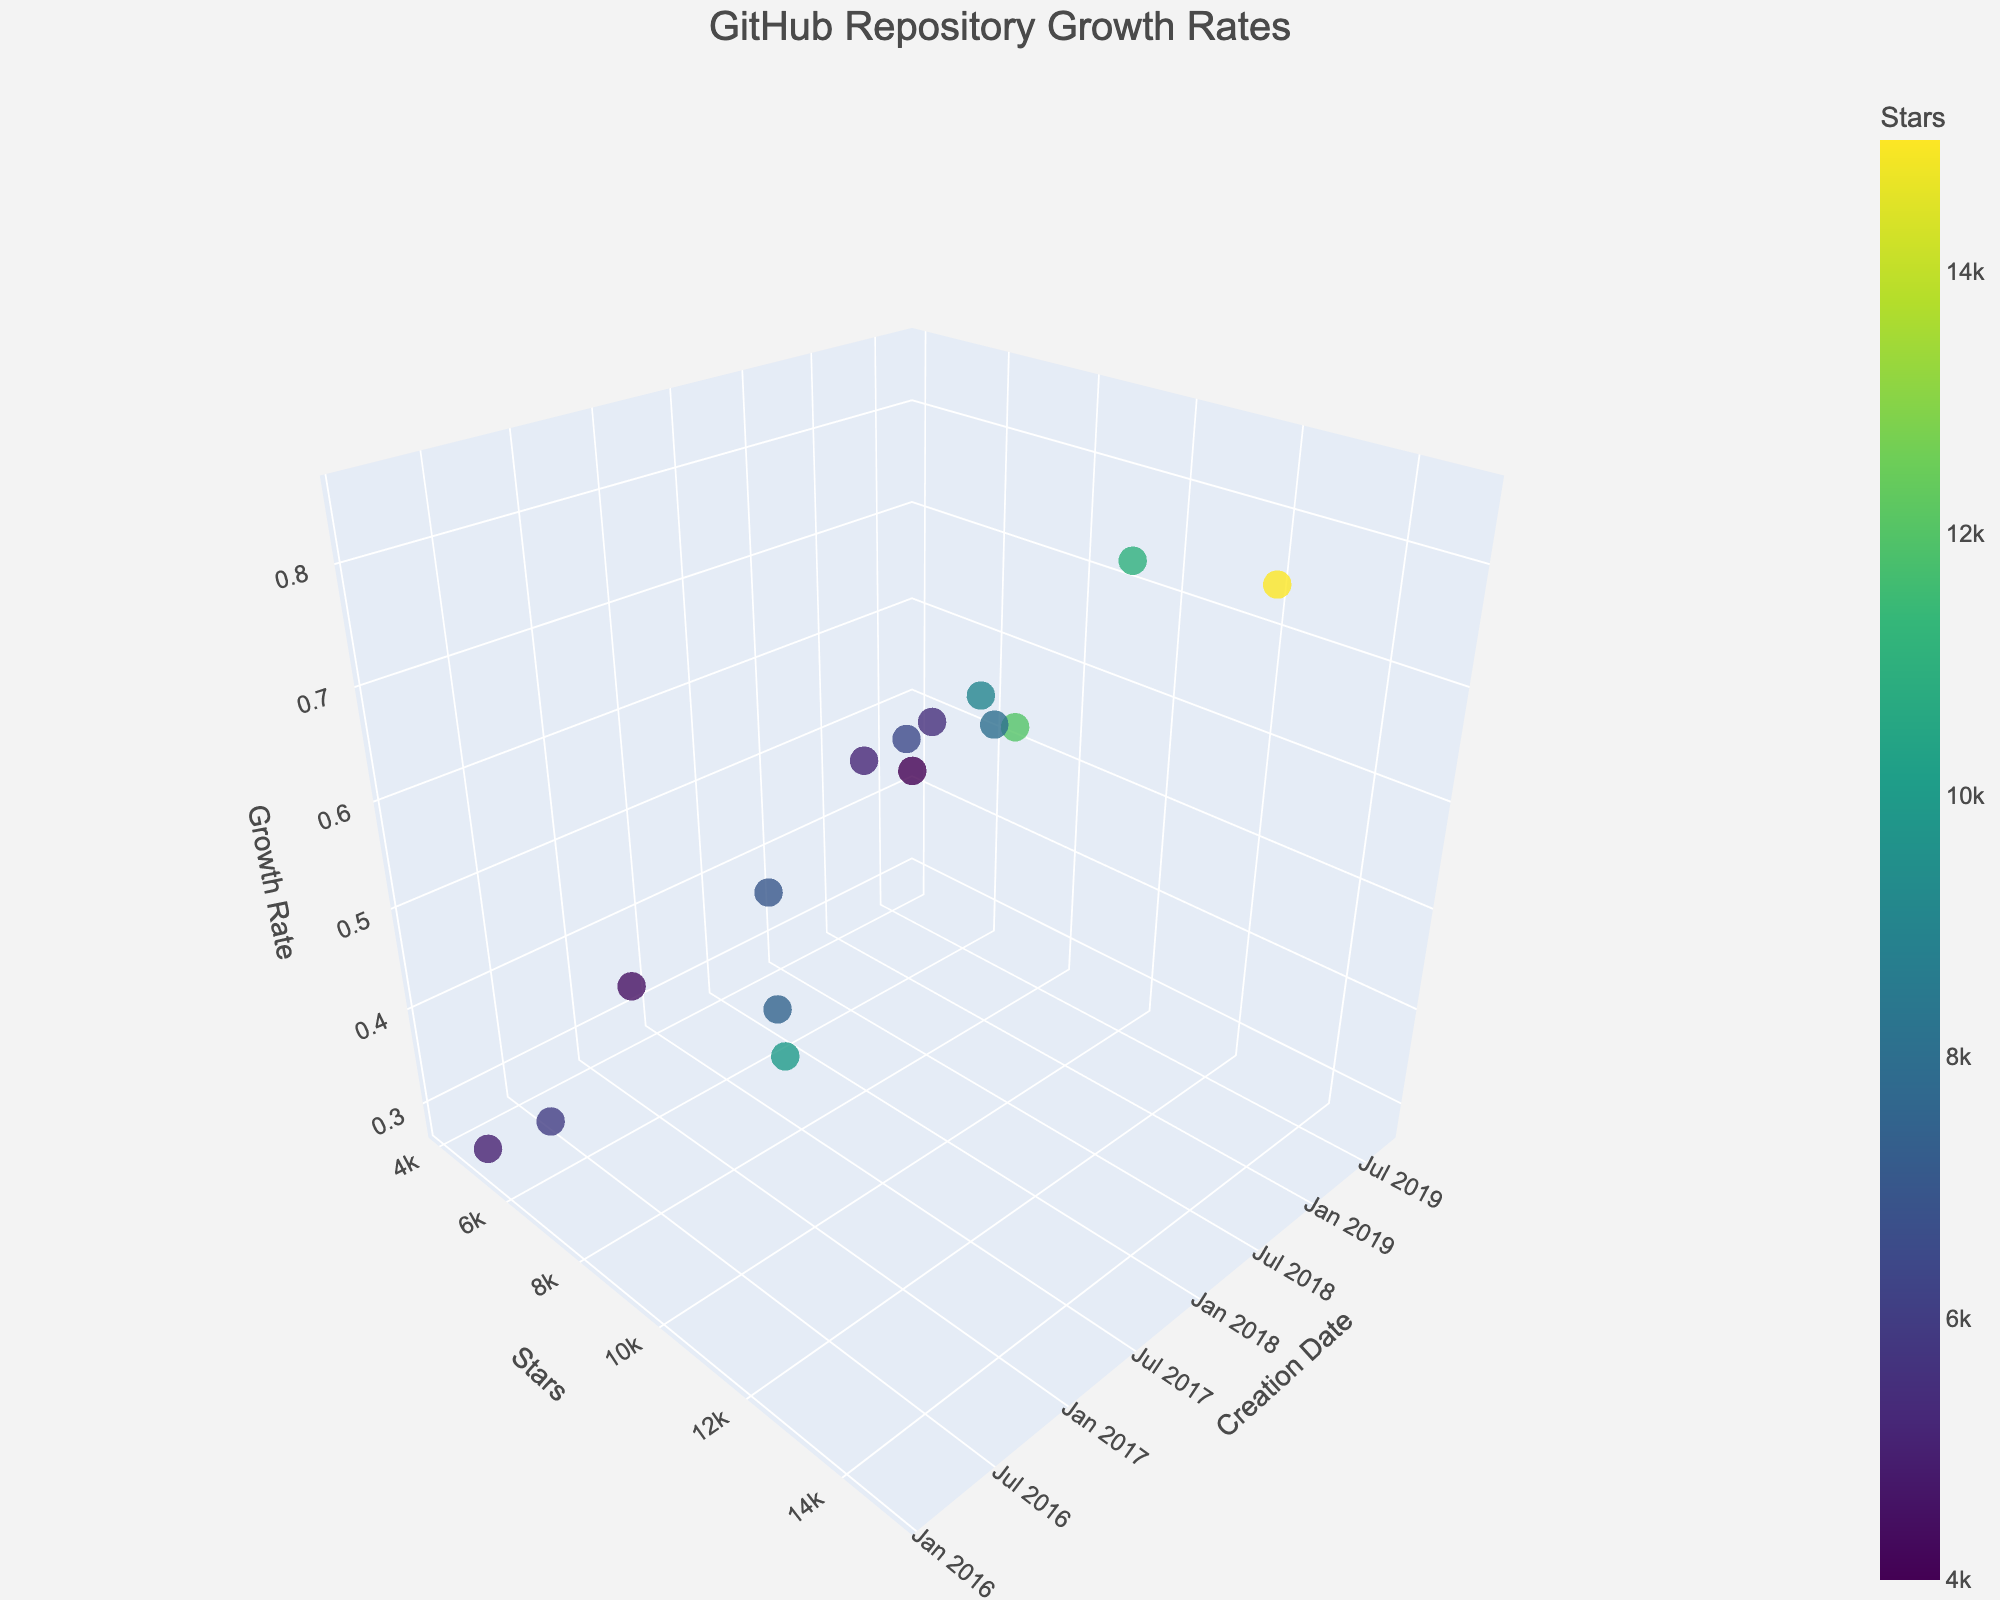What is the title of the 3D plot? The title is located at the top of the plot in a larger font size and might be centered. The title provides a brief description of what the plot represents.
Answer: GitHub Repository Growth Rates How many programming languages are plotted in the figure? To determine the number of programming languages, count the total number of unique data points represented by different colored markers.
Answer: 15 Which programming language has the highest star count? To find the language with the highest star count, look for the marker positioned highest on the y-axis. Check the hover text for the language's name.
Answer: Python What range of dates is represented on the x-axis? Examine the x-axis labels to see the earliest and latest creation dates shown on the plot.
Answer: From 2016 to 2019 Which programming language shows the highest growth rate? Locate the marker positioned highest on the z-axis. The hover text will reveal the corresponding programming language.
Answer: Python Which language created around mid-2018 has a higher growth rate, Go or TypeScript? Compare the markers for Go and TypeScript around the mid-2018 date on the x-axis. Check their positions relative to the z-axis for growth rates.
Answer: Go On average, do newer repositories (created after 2018) have higher growth rates compared to older ones? Identify the markers for repositories created after 2018 and those before. Compare their average z-axis values.
Answer: Yes How does the star count of the Ruby repository compare to the JavaScript repository? Look for the Ruby and JavaScript markers on the y-axis to compare their star counts directly.
Answer: JavaScript has more stars Which programming language from those visualized shows the lowest growth rate? Find the marker positioned lowest on the z-axis. Check the hover text for the corresponding language.
Answer: PHP Is there a noticeable trend between the creation date and growth rate of repositories? Observe if there is a pattern where newer or older repositories tend to have higher or lower growth rates based on their positioning on the z-axis.
Answer: Yes, newer repositories typically have higher growth rates 